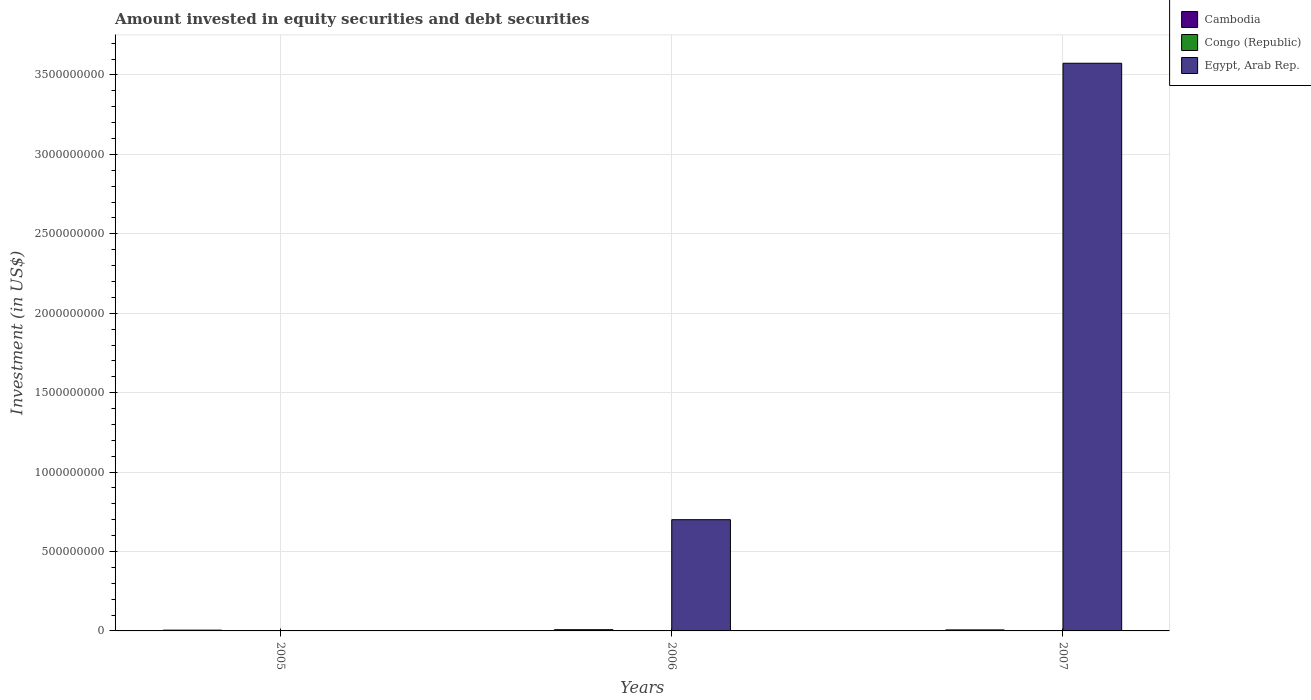Are the number of bars per tick equal to the number of legend labels?
Provide a succinct answer. No. How many bars are there on the 1st tick from the right?
Give a very brief answer. 3. What is the label of the 2nd group of bars from the left?
Ensure brevity in your answer.  2006. What is the amount invested in equity securities and debt securities in Egypt, Arab Rep. in 2007?
Ensure brevity in your answer.  3.57e+09. Across all years, what is the maximum amount invested in equity securities and debt securities in Congo (Republic)?
Provide a succinct answer. 1.46e+06. Across all years, what is the minimum amount invested in equity securities and debt securities in Egypt, Arab Rep.?
Your answer should be very brief. 0. What is the total amount invested in equity securities and debt securities in Egypt, Arab Rep. in the graph?
Your answer should be very brief. 4.27e+09. What is the difference between the amount invested in equity securities and debt securities in Congo (Republic) in 2005 and that in 2007?
Give a very brief answer. -3.23e+05. What is the difference between the amount invested in equity securities and debt securities in Egypt, Arab Rep. in 2007 and the amount invested in equity securities and debt securities in Congo (Republic) in 2006?
Your answer should be very brief. 3.57e+09. What is the average amount invested in equity securities and debt securities in Cambodia per year?
Provide a short and direct response. 6.26e+06. In the year 2006, what is the difference between the amount invested in equity securities and debt securities in Egypt, Arab Rep. and amount invested in equity securities and debt securities in Congo (Republic)?
Your answer should be compact. 6.99e+08. What is the ratio of the amount invested in equity securities and debt securities in Cambodia in 2005 to that in 2007?
Provide a short and direct response. 0.77. Is the amount invested in equity securities and debt securities in Cambodia in 2005 less than that in 2007?
Offer a very short reply. Yes. What is the difference between the highest and the second highest amount invested in equity securities and debt securities in Cambodia?
Your response must be concise. 1.25e+06. What is the difference between the highest and the lowest amount invested in equity securities and debt securities in Congo (Republic)?
Offer a terse response. 3.23e+05. Is it the case that in every year, the sum of the amount invested in equity securities and debt securities in Cambodia and amount invested in equity securities and debt securities in Egypt, Arab Rep. is greater than the amount invested in equity securities and debt securities in Congo (Republic)?
Your answer should be very brief. Yes. How many bars are there?
Make the answer very short. 8. How many years are there in the graph?
Make the answer very short. 3. What is the difference between two consecutive major ticks on the Y-axis?
Offer a very short reply. 5.00e+08. Are the values on the major ticks of Y-axis written in scientific E-notation?
Ensure brevity in your answer.  No. How many legend labels are there?
Your answer should be very brief. 3. How are the legend labels stacked?
Your answer should be compact. Vertical. What is the title of the graph?
Your response must be concise. Amount invested in equity securities and debt securities. What is the label or title of the X-axis?
Provide a short and direct response. Years. What is the label or title of the Y-axis?
Make the answer very short. Investment (in US$). What is the Investment (in US$) of Cambodia in 2005?
Offer a terse response. 4.87e+06. What is the Investment (in US$) in Congo (Republic) in 2005?
Provide a short and direct response. 1.14e+06. What is the Investment (in US$) of Egypt, Arab Rep. in 2005?
Your answer should be very brief. 0. What is the Investment (in US$) in Cambodia in 2006?
Ensure brevity in your answer.  7.58e+06. What is the Investment (in US$) in Congo (Republic) in 2006?
Make the answer very short. 1.34e+06. What is the Investment (in US$) in Egypt, Arab Rep. in 2006?
Your answer should be compact. 7.00e+08. What is the Investment (in US$) of Cambodia in 2007?
Offer a terse response. 6.33e+06. What is the Investment (in US$) of Congo (Republic) in 2007?
Make the answer very short. 1.46e+06. What is the Investment (in US$) of Egypt, Arab Rep. in 2007?
Ensure brevity in your answer.  3.57e+09. Across all years, what is the maximum Investment (in US$) in Cambodia?
Your response must be concise. 7.58e+06. Across all years, what is the maximum Investment (in US$) of Congo (Republic)?
Make the answer very short. 1.46e+06. Across all years, what is the maximum Investment (in US$) in Egypt, Arab Rep.?
Your answer should be very brief. 3.57e+09. Across all years, what is the minimum Investment (in US$) of Cambodia?
Keep it short and to the point. 4.87e+06. Across all years, what is the minimum Investment (in US$) in Congo (Republic)?
Your answer should be very brief. 1.14e+06. What is the total Investment (in US$) in Cambodia in the graph?
Give a very brief answer. 1.88e+07. What is the total Investment (in US$) of Congo (Republic) in the graph?
Your response must be concise. 3.94e+06. What is the total Investment (in US$) in Egypt, Arab Rep. in the graph?
Make the answer very short. 4.27e+09. What is the difference between the Investment (in US$) in Cambodia in 2005 and that in 2006?
Your response must be concise. -2.72e+06. What is the difference between the Investment (in US$) in Congo (Republic) in 2005 and that in 2006?
Provide a short and direct response. -2.01e+05. What is the difference between the Investment (in US$) in Cambodia in 2005 and that in 2007?
Give a very brief answer. -1.47e+06. What is the difference between the Investment (in US$) in Congo (Republic) in 2005 and that in 2007?
Offer a terse response. -3.23e+05. What is the difference between the Investment (in US$) in Cambodia in 2006 and that in 2007?
Your answer should be very brief. 1.25e+06. What is the difference between the Investment (in US$) of Congo (Republic) in 2006 and that in 2007?
Your answer should be compact. -1.22e+05. What is the difference between the Investment (in US$) in Egypt, Arab Rep. in 2006 and that in 2007?
Give a very brief answer. -2.87e+09. What is the difference between the Investment (in US$) in Cambodia in 2005 and the Investment (in US$) in Congo (Republic) in 2006?
Give a very brief answer. 3.53e+06. What is the difference between the Investment (in US$) of Cambodia in 2005 and the Investment (in US$) of Egypt, Arab Rep. in 2006?
Make the answer very short. -6.96e+08. What is the difference between the Investment (in US$) of Congo (Republic) in 2005 and the Investment (in US$) of Egypt, Arab Rep. in 2006?
Your answer should be compact. -6.99e+08. What is the difference between the Investment (in US$) of Cambodia in 2005 and the Investment (in US$) of Congo (Republic) in 2007?
Your answer should be compact. 3.41e+06. What is the difference between the Investment (in US$) in Cambodia in 2005 and the Investment (in US$) in Egypt, Arab Rep. in 2007?
Your response must be concise. -3.57e+09. What is the difference between the Investment (in US$) in Congo (Republic) in 2005 and the Investment (in US$) in Egypt, Arab Rep. in 2007?
Keep it short and to the point. -3.57e+09. What is the difference between the Investment (in US$) in Cambodia in 2006 and the Investment (in US$) in Congo (Republic) in 2007?
Provide a succinct answer. 6.12e+06. What is the difference between the Investment (in US$) of Cambodia in 2006 and the Investment (in US$) of Egypt, Arab Rep. in 2007?
Provide a succinct answer. -3.57e+09. What is the difference between the Investment (in US$) in Congo (Republic) in 2006 and the Investment (in US$) in Egypt, Arab Rep. in 2007?
Provide a succinct answer. -3.57e+09. What is the average Investment (in US$) of Cambodia per year?
Your answer should be compact. 6.26e+06. What is the average Investment (in US$) in Congo (Republic) per year?
Provide a short and direct response. 1.31e+06. What is the average Investment (in US$) in Egypt, Arab Rep. per year?
Ensure brevity in your answer.  1.42e+09. In the year 2005, what is the difference between the Investment (in US$) in Cambodia and Investment (in US$) in Congo (Republic)?
Your answer should be compact. 3.73e+06. In the year 2006, what is the difference between the Investment (in US$) of Cambodia and Investment (in US$) of Congo (Republic)?
Give a very brief answer. 6.24e+06. In the year 2006, what is the difference between the Investment (in US$) in Cambodia and Investment (in US$) in Egypt, Arab Rep.?
Provide a succinct answer. -6.93e+08. In the year 2006, what is the difference between the Investment (in US$) in Congo (Republic) and Investment (in US$) in Egypt, Arab Rep.?
Offer a terse response. -6.99e+08. In the year 2007, what is the difference between the Investment (in US$) in Cambodia and Investment (in US$) in Congo (Republic)?
Provide a succinct answer. 4.87e+06. In the year 2007, what is the difference between the Investment (in US$) in Cambodia and Investment (in US$) in Egypt, Arab Rep.?
Provide a short and direct response. -3.57e+09. In the year 2007, what is the difference between the Investment (in US$) of Congo (Republic) and Investment (in US$) of Egypt, Arab Rep.?
Offer a very short reply. -3.57e+09. What is the ratio of the Investment (in US$) in Cambodia in 2005 to that in 2006?
Your response must be concise. 0.64. What is the ratio of the Investment (in US$) in Congo (Republic) in 2005 to that in 2006?
Keep it short and to the point. 0.85. What is the ratio of the Investment (in US$) of Cambodia in 2005 to that in 2007?
Make the answer very short. 0.77. What is the ratio of the Investment (in US$) in Congo (Republic) in 2005 to that in 2007?
Provide a short and direct response. 0.78. What is the ratio of the Investment (in US$) of Cambodia in 2006 to that in 2007?
Give a very brief answer. 1.2. What is the ratio of the Investment (in US$) in Congo (Republic) in 2006 to that in 2007?
Give a very brief answer. 0.92. What is the ratio of the Investment (in US$) of Egypt, Arab Rep. in 2006 to that in 2007?
Provide a succinct answer. 0.2. What is the difference between the highest and the second highest Investment (in US$) of Cambodia?
Offer a very short reply. 1.25e+06. What is the difference between the highest and the second highest Investment (in US$) in Congo (Republic)?
Keep it short and to the point. 1.22e+05. What is the difference between the highest and the lowest Investment (in US$) of Cambodia?
Your answer should be very brief. 2.72e+06. What is the difference between the highest and the lowest Investment (in US$) in Congo (Republic)?
Your response must be concise. 3.23e+05. What is the difference between the highest and the lowest Investment (in US$) in Egypt, Arab Rep.?
Keep it short and to the point. 3.57e+09. 